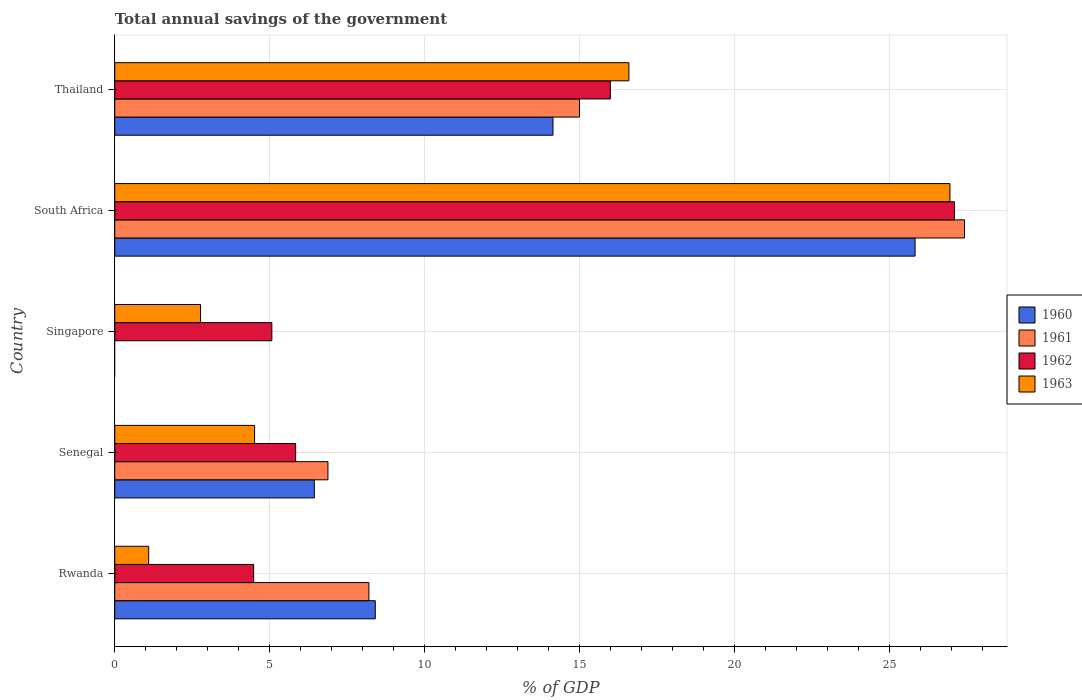How many different coloured bars are there?
Give a very brief answer. 4. Are the number of bars on each tick of the Y-axis equal?
Make the answer very short. No. What is the label of the 2nd group of bars from the top?
Offer a terse response. South Africa. What is the total annual savings of the government in 1960 in Thailand?
Ensure brevity in your answer.  14.13. Across all countries, what is the maximum total annual savings of the government in 1960?
Ensure brevity in your answer.  25.81. In which country was the total annual savings of the government in 1963 maximum?
Make the answer very short. South Africa. What is the total total annual savings of the government in 1962 in the graph?
Make the answer very short. 58.45. What is the difference between the total annual savings of the government in 1961 in Rwanda and that in Thailand?
Provide a short and direct response. -6.79. What is the difference between the total annual savings of the government in 1960 in Rwanda and the total annual savings of the government in 1961 in Senegal?
Provide a succinct answer. 1.53. What is the average total annual savings of the government in 1961 per country?
Keep it short and to the point. 11.49. What is the difference between the total annual savings of the government in 1960 and total annual savings of the government in 1963 in South Africa?
Your answer should be very brief. -1.13. What is the ratio of the total annual savings of the government in 1963 in Senegal to that in Singapore?
Keep it short and to the point. 1.63. Is the total annual savings of the government in 1962 in Rwanda less than that in Thailand?
Provide a succinct answer. Yes. What is the difference between the highest and the second highest total annual savings of the government in 1960?
Ensure brevity in your answer.  11.68. What is the difference between the highest and the lowest total annual savings of the government in 1960?
Provide a succinct answer. 25.81. In how many countries, is the total annual savings of the government in 1961 greater than the average total annual savings of the government in 1961 taken over all countries?
Provide a short and direct response. 2. Is the sum of the total annual savings of the government in 1961 in South Africa and Thailand greater than the maximum total annual savings of the government in 1962 across all countries?
Make the answer very short. Yes. Is it the case that in every country, the sum of the total annual savings of the government in 1961 and total annual savings of the government in 1962 is greater than the total annual savings of the government in 1960?
Your response must be concise. Yes. How many bars are there?
Your response must be concise. 18. Are all the bars in the graph horizontal?
Keep it short and to the point. Yes. What is the difference between two consecutive major ticks on the X-axis?
Your answer should be compact. 5. Are the values on the major ticks of X-axis written in scientific E-notation?
Give a very brief answer. No. How are the legend labels stacked?
Give a very brief answer. Vertical. What is the title of the graph?
Your answer should be very brief. Total annual savings of the government. What is the label or title of the X-axis?
Your answer should be compact. % of GDP. What is the label or title of the Y-axis?
Your answer should be compact. Country. What is the % of GDP in 1960 in Rwanda?
Give a very brief answer. 8.4. What is the % of GDP in 1961 in Rwanda?
Ensure brevity in your answer.  8.2. What is the % of GDP in 1962 in Rwanda?
Provide a succinct answer. 4.48. What is the % of GDP in 1963 in Rwanda?
Make the answer very short. 1.09. What is the % of GDP in 1960 in Senegal?
Provide a short and direct response. 6.44. What is the % of GDP of 1961 in Senegal?
Give a very brief answer. 6.88. What is the % of GDP in 1962 in Senegal?
Provide a succinct answer. 5.83. What is the % of GDP in 1963 in Senegal?
Keep it short and to the point. 4.51. What is the % of GDP of 1962 in Singapore?
Offer a very short reply. 5.07. What is the % of GDP of 1963 in Singapore?
Your answer should be compact. 2.77. What is the % of GDP of 1960 in South Africa?
Your answer should be compact. 25.81. What is the % of GDP of 1961 in South Africa?
Your answer should be compact. 27.41. What is the % of GDP of 1962 in South Africa?
Ensure brevity in your answer.  27.08. What is the % of GDP in 1963 in South Africa?
Ensure brevity in your answer.  26.94. What is the % of GDP of 1960 in Thailand?
Keep it short and to the point. 14.13. What is the % of GDP of 1961 in Thailand?
Your response must be concise. 14.99. What is the % of GDP of 1962 in Thailand?
Ensure brevity in your answer.  15.99. What is the % of GDP of 1963 in Thailand?
Your answer should be compact. 16.58. Across all countries, what is the maximum % of GDP in 1960?
Your response must be concise. 25.81. Across all countries, what is the maximum % of GDP of 1961?
Your answer should be very brief. 27.41. Across all countries, what is the maximum % of GDP in 1962?
Your response must be concise. 27.08. Across all countries, what is the maximum % of GDP in 1963?
Your answer should be very brief. 26.94. Across all countries, what is the minimum % of GDP in 1960?
Your answer should be compact. 0. Across all countries, what is the minimum % of GDP of 1962?
Ensure brevity in your answer.  4.48. Across all countries, what is the minimum % of GDP in 1963?
Make the answer very short. 1.09. What is the total % of GDP in 1960 in the graph?
Your answer should be very brief. 54.79. What is the total % of GDP in 1961 in the graph?
Provide a short and direct response. 57.47. What is the total % of GDP in 1962 in the graph?
Keep it short and to the point. 58.45. What is the total % of GDP in 1963 in the graph?
Keep it short and to the point. 51.9. What is the difference between the % of GDP of 1960 in Rwanda and that in Senegal?
Offer a terse response. 1.97. What is the difference between the % of GDP in 1961 in Rwanda and that in Senegal?
Your answer should be compact. 1.32. What is the difference between the % of GDP of 1962 in Rwanda and that in Senegal?
Your answer should be compact. -1.35. What is the difference between the % of GDP in 1963 in Rwanda and that in Senegal?
Keep it short and to the point. -3.42. What is the difference between the % of GDP of 1962 in Rwanda and that in Singapore?
Offer a terse response. -0.59. What is the difference between the % of GDP in 1963 in Rwanda and that in Singapore?
Ensure brevity in your answer.  -1.67. What is the difference between the % of GDP in 1960 in Rwanda and that in South Africa?
Ensure brevity in your answer.  -17.41. What is the difference between the % of GDP in 1961 in Rwanda and that in South Africa?
Ensure brevity in your answer.  -19.21. What is the difference between the % of GDP of 1962 in Rwanda and that in South Africa?
Your answer should be compact. -22.6. What is the difference between the % of GDP in 1963 in Rwanda and that in South Africa?
Ensure brevity in your answer.  -25.85. What is the difference between the % of GDP in 1960 in Rwanda and that in Thailand?
Make the answer very short. -5.73. What is the difference between the % of GDP of 1961 in Rwanda and that in Thailand?
Ensure brevity in your answer.  -6.79. What is the difference between the % of GDP of 1962 in Rwanda and that in Thailand?
Offer a very short reply. -11.51. What is the difference between the % of GDP in 1963 in Rwanda and that in Thailand?
Offer a very short reply. -15.49. What is the difference between the % of GDP in 1962 in Senegal and that in Singapore?
Provide a short and direct response. 0.77. What is the difference between the % of GDP in 1963 in Senegal and that in Singapore?
Make the answer very short. 1.74. What is the difference between the % of GDP of 1960 in Senegal and that in South Africa?
Offer a very short reply. -19.38. What is the difference between the % of GDP in 1961 in Senegal and that in South Africa?
Offer a very short reply. -20.53. What is the difference between the % of GDP of 1962 in Senegal and that in South Africa?
Offer a very short reply. -21.25. What is the difference between the % of GDP in 1963 in Senegal and that in South Africa?
Offer a terse response. -22.43. What is the difference between the % of GDP of 1960 in Senegal and that in Thailand?
Offer a very short reply. -7.7. What is the difference between the % of GDP of 1961 in Senegal and that in Thailand?
Your answer should be compact. -8.11. What is the difference between the % of GDP in 1962 in Senegal and that in Thailand?
Your answer should be compact. -10.15. What is the difference between the % of GDP of 1963 in Senegal and that in Thailand?
Your answer should be very brief. -12.07. What is the difference between the % of GDP in 1962 in Singapore and that in South Africa?
Give a very brief answer. -22.02. What is the difference between the % of GDP in 1963 in Singapore and that in South Africa?
Ensure brevity in your answer.  -24.17. What is the difference between the % of GDP in 1962 in Singapore and that in Thailand?
Provide a short and direct response. -10.92. What is the difference between the % of GDP in 1963 in Singapore and that in Thailand?
Offer a very short reply. -13.82. What is the difference between the % of GDP in 1960 in South Africa and that in Thailand?
Offer a very short reply. 11.68. What is the difference between the % of GDP in 1961 in South Africa and that in Thailand?
Your answer should be very brief. 12.42. What is the difference between the % of GDP in 1962 in South Africa and that in Thailand?
Your answer should be very brief. 11.1. What is the difference between the % of GDP of 1963 in South Africa and that in Thailand?
Ensure brevity in your answer.  10.36. What is the difference between the % of GDP of 1960 in Rwanda and the % of GDP of 1961 in Senegal?
Offer a terse response. 1.53. What is the difference between the % of GDP in 1960 in Rwanda and the % of GDP in 1962 in Senegal?
Make the answer very short. 2.57. What is the difference between the % of GDP of 1960 in Rwanda and the % of GDP of 1963 in Senegal?
Your answer should be very brief. 3.89. What is the difference between the % of GDP in 1961 in Rwanda and the % of GDP in 1962 in Senegal?
Make the answer very short. 2.36. What is the difference between the % of GDP of 1961 in Rwanda and the % of GDP of 1963 in Senegal?
Make the answer very short. 3.69. What is the difference between the % of GDP of 1962 in Rwanda and the % of GDP of 1963 in Senegal?
Make the answer very short. -0.03. What is the difference between the % of GDP of 1960 in Rwanda and the % of GDP of 1962 in Singapore?
Your response must be concise. 3.34. What is the difference between the % of GDP in 1960 in Rwanda and the % of GDP in 1963 in Singapore?
Your response must be concise. 5.64. What is the difference between the % of GDP in 1961 in Rwanda and the % of GDP in 1962 in Singapore?
Make the answer very short. 3.13. What is the difference between the % of GDP in 1961 in Rwanda and the % of GDP in 1963 in Singapore?
Offer a very short reply. 5.43. What is the difference between the % of GDP in 1962 in Rwanda and the % of GDP in 1963 in Singapore?
Provide a succinct answer. 1.71. What is the difference between the % of GDP in 1960 in Rwanda and the % of GDP in 1961 in South Africa?
Offer a very short reply. -19.01. What is the difference between the % of GDP in 1960 in Rwanda and the % of GDP in 1962 in South Africa?
Your response must be concise. -18.68. What is the difference between the % of GDP of 1960 in Rwanda and the % of GDP of 1963 in South Africa?
Offer a very short reply. -18.54. What is the difference between the % of GDP in 1961 in Rwanda and the % of GDP in 1962 in South Africa?
Your response must be concise. -18.89. What is the difference between the % of GDP in 1961 in Rwanda and the % of GDP in 1963 in South Africa?
Your response must be concise. -18.74. What is the difference between the % of GDP of 1962 in Rwanda and the % of GDP of 1963 in South Africa?
Provide a short and direct response. -22.46. What is the difference between the % of GDP of 1960 in Rwanda and the % of GDP of 1961 in Thailand?
Ensure brevity in your answer.  -6.59. What is the difference between the % of GDP in 1960 in Rwanda and the % of GDP in 1962 in Thailand?
Give a very brief answer. -7.58. What is the difference between the % of GDP of 1960 in Rwanda and the % of GDP of 1963 in Thailand?
Your response must be concise. -8.18. What is the difference between the % of GDP in 1961 in Rwanda and the % of GDP in 1962 in Thailand?
Offer a terse response. -7.79. What is the difference between the % of GDP in 1961 in Rwanda and the % of GDP in 1963 in Thailand?
Your response must be concise. -8.39. What is the difference between the % of GDP in 1962 in Rwanda and the % of GDP in 1963 in Thailand?
Your response must be concise. -12.1. What is the difference between the % of GDP of 1960 in Senegal and the % of GDP of 1962 in Singapore?
Your response must be concise. 1.37. What is the difference between the % of GDP of 1960 in Senegal and the % of GDP of 1963 in Singapore?
Your answer should be very brief. 3.67. What is the difference between the % of GDP of 1961 in Senegal and the % of GDP of 1962 in Singapore?
Your response must be concise. 1.81. What is the difference between the % of GDP in 1961 in Senegal and the % of GDP in 1963 in Singapore?
Your response must be concise. 4.11. What is the difference between the % of GDP in 1962 in Senegal and the % of GDP in 1963 in Singapore?
Make the answer very short. 3.07. What is the difference between the % of GDP of 1960 in Senegal and the % of GDP of 1961 in South Africa?
Give a very brief answer. -20.97. What is the difference between the % of GDP of 1960 in Senegal and the % of GDP of 1962 in South Africa?
Offer a terse response. -20.65. What is the difference between the % of GDP in 1960 in Senegal and the % of GDP in 1963 in South Africa?
Your answer should be compact. -20.5. What is the difference between the % of GDP in 1961 in Senegal and the % of GDP in 1962 in South Africa?
Your answer should be very brief. -20.21. What is the difference between the % of GDP in 1961 in Senegal and the % of GDP in 1963 in South Africa?
Ensure brevity in your answer.  -20.06. What is the difference between the % of GDP in 1962 in Senegal and the % of GDP in 1963 in South Africa?
Your answer should be compact. -21.11. What is the difference between the % of GDP of 1960 in Senegal and the % of GDP of 1961 in Thailand?
Offer a very short reply. -8.55. What is the difference between the % of GDP in 1960 in Senegal and the % of GDP in 1962 in Thailand?
Ensure brevity in your answer.  -9.55. What is the difference between the % of GDP in 1960 in Senegal and the % of GDP in 1963 in Thailand?
Ensure brevity in your answer.  -10.15. What is the difference between the % of GDP in 1961 in Senegal and the % of GDP in 1962 in Thailand?
Keep it short and to the point. -9.11. What is the difference between the % of GDP of 1961 in Senegal and the % of GDP of 1963 in Thailand?
Provide a short and direct response. -9.71. What is the difference between the % of GDP in 1962 in Senegal and the % of GDP in 1963 in Thailand?
Offer a terse response. -10.75. What is the difference between the % of GDP in 1962 in Singapore and the % of GDP in 1963 in South Africa?
Provide a short and direct response. -21.87. What is the difference between the % of GDP of 1962 in Singapore and the % of GDP of 1963 in Thailand?
Give a very brief answer. -11.52. What is the difference between the % of GDP of 1960 in South Africa and the % of GDP of 1961 in Thailand?
Your response must be concise. 10.83. What is the difference between the % of GDP in 1960 in South Africa and the % of GDP in 1962 in Thailand?
Give a very brief answer. 9.83. What is the difference between the % of GDP of 1960 in South Africa and the % of GDP of 1963 in Thailand?
Your answer should be very brief. 9.23. What is the difference between the % of GDP of 1961 in South Africa and the % of GDP of 1962 in Thailand?
Offer a terse response. 11.42. What is the difference between the % of GDP of 1961 in South Africa and the % of GDP of 1963 in Thailand?
Keep it short and to the point. 10.82. What is the difference between the % of GDP of 1962 in South Africa and the % of GDP of 1963 in Thailand?
Offer a terse response. 10.5. What is the average % of GDP of 1960 per country?
Offer a terse response. 10.96. What is the average % of GDP in 1961 per country?
Provide a succinct answer. 11.49. What is the average % of GDP in 1962 per country?
Offer a terse response. 11.69. What is the average % of GDP in 1963 per country?
Provide a short and direct response. 10.38. What is the difference between the % of GDP of 1960 and % of GDP of 1961 in Rwanda?
Make the answer very short. 0.21. What is the difference between the % of GDP of 1960 and % of GDP of 1962 in Rwanda?
Provide a succinct answer. 3.92. What is the difference between the % of GDP in 1960 and % of GDP in 1963 in Rwanda?
Your answer should be very brief. 7.31. What is the difference between the % of GDP of 1961 and % of GDP of 1962 in Rwanda?
Make the answer very short. 3.72. What is the difference between the % of GDP in 1961 and % of GDP in 1963 in Rwanda?
Offer a terse response. 7.1. What is the difference between the % of GDP of 1962 and % of GDP of 1963 in Rwanda?
Make the answer very short. 3.39. What is the difference between the % of GDP of 1960 and % of GDP of 1961 in Senegal?
Provide a succinct answer. -0.44. What is the difference between the % of GDP of 1960 and % of GDP of 1962 in Senegal?
Provide a short and direct response. 0.6. What is the difference between the % of GDP of 1960 and % of GDP of 1963 in Senegal?
Offer a very short reply. 1.93. What is the difference between the % of GDP in 1961 and % of GDP in 1962 in Senegal?
Make the answer very short. 1.04. What is the difference between the % of GDP in 1961 and % of GDP in 1963 in Senegal?
Make the answer very short. 2.37. What is the difference between the % of GDP of 1962 and % of GDP of 1963 in Senegal?
Offer a very short reply. 1.32. What is the difference between the % of GDP in 1962 and % of GDP in 1963 in Singapore?
Your answer should be compact. 2.3. What is the difference between the % of GDP of 1960 and % of GDP of 1961 in South Africa?
Make the answer very short. -1.59. What is the difference between the % of GDP of 1960 and % of GDP of 1962 in South Africa?
Ensure brevity in your answer.  -1.27. What is the difference between the % of GDP in 1960 and % of GDP in 1963 in South Africa?
Your response must be concise. -1.13. What is the difference between the % of GDP in 1961 and % of GDP in 1962 in South Africa?
Your answer should be compact. 0.33. What is the difference between the % of GDP of 1961 and % of GDP of 1963 in South Africa?
Give a very brief answer. 0.47. What is the difference between the % of GDP of 1962 and % of GDP of 1963 in South Africa?
Provide a succinct answer. 0.14. What is the difference between the % of GDP of 1960 and % of GDP of 1961 in Thailand?
Ensure brevity in your answer.  -0.85. What is the difference between the % of GDP in 1960 and % of GDP in 1962 in Thailand?
Your answer should be compact. -1.85. What is the difference between the % of GDP in 1960 and % of GDP in 1963 in Thailand?
Your answer should be very brief. -2.45. What is the difference between the % of GDP of 1961 and % of GDP of 1962 in Thailand?
Your answer should be compact. -1. What is the difference between the % of GDP in 1961 and % of GDP in 1963 in Thailand?
Provide a succinct answer. -1.59. What is the difference between the % of GDP of 1962 and % of GDP of 1963 in Thailand?
Ensure brevity in your answer.  -0.6. What is the ratio of the % of GDP of 1960 in Rwanda to that in Senegal?
Make the answer very short. 1.31. What is the ratio of the % of GDP in 1961 in Rwanda to that in Senegal?
Your answer should be very brief. 1.19. What is the ratio of the % of GDP of 1962 in Rwanda to that in Senegal?
Offer a very short reply. 0.77. What is the ratio of the % of GDP in 1963 in Rwanda to that in Senegal?
Ensure brevity in your answer.  0.24. What is the ratio of the % of GDP of 1962 in Rwanda to that in Singapore?
Your answer should be very brief. 0.88. What is the ratio of the % of GDP of 1963 in Rwanda to that in Singapore?
Keep it short and to the point. 0.4. What is the ratio of the % of GDP of 1960 in Rwanda to that in South Africa?
Ensure brevity in your answer.  0.33. What is the ratio of the % of GDP of 1961 in Rwanda to that in South Africa?
Your response must be concise. 0.3. What is the ratio of the % of GDP in 1962 in Rwanda to that in South Africa?
Your answer should be very brief. 0.17. What is the ratio of the % of GDP of 1963 in Rwanda to that in South Africa?
Your response must be concise. 0.04. What is the ratio of the % of GDP in 1960 in Rwanda to that in Thailand?
Provide a succinct answer. 0.59. What is the ratio of the % of GDP of 1961 in Rwanda to that in Thailand?
Offer a terse response. 0.55. What is the ratio of the % of GDP in 1962 in Rwanda to that in Thailand?
Give a very brief answer. 0.28. What is the ratio of the % of GDP in 1963 in Rwanda to that in Thailand?
Make the answer very short. 0.07. What is the ratio of the % of GDP of 1962 in Senegal to that in Singapore?
Your answer should be very brief. 1.15. What is the ratio of the % of GDP in 1963 in Senegal to that in Singapore?
Keep it short and to the point. 1.63. What is the ratio of the % of GDP in 1960 in Senegal to that in South Africa?
Make the answer very short. 0.25. What is the ratio of the % of GDP in 1961 in Senegal to that in South Africa?
Provide a succinct answer. 0.25. What is the ratio of the % of GDP of 1962 in Senegal to that in South Africa?
Keep it short and to the point. 0.22. What is the ratio of the % of GDP of 1963 in Senegal to that in South Africa?
Your answer should be very brief. 0.17. What is the ratio of the % of GDP in 1960 in Senegal to that in Thailand?
Your response must be concise. 0.46. What is the ratio of the % of GDP of 1961 in Senegal to that in Thailand?
Your answer should be very brief. 0.46. What is the ratio of the % of GDP in 1962 in Senegal to that in Thailand?
Offer a terse response. 0.36. What is the ratio of the % of GDP in 1963 in Senegal to that in Thailand?
Provide a succinct answer. 0.27. What is the ratio of the % of GDP of 1962 in Singapore to that in South Africa?
Offer a very short reply. 0.19. What is the ratio of the % of GDP of 1963 in Singapore to that in South Africa?
Ensure brevity in your answer.  0.1. What is the ratio of the % of GDP in 1962 in Singapore to that in Thailand?
Your answer should be compact. 0.32. What is the ratio of the % of GDP in 1963 in Singapore to that in Thailand?
Offer a very short reply. 0.17. What is the ratio of the % of GDP of 1960 in South Africa to that in Thailand?
Offer a very short reply. 1.83. What is the ratio of the % of GDP of 1961 in South Africa to that in Thailand?
Make the answer very short. 1.83. What is the ratio of the % of GDP in 1962 in South Africa to that in Thailand?
Make the answer very short. 1.69. What is the ratio of the % of GDP in 1963 in South Africa to that in Thailand?
Make the answer very short. 1.62. What is the difference between the highest and the second highest % of GDP of 1960?
Keep it short and to the point. 11.68. What is the difference between the highest and the second highest % of GDP in 1961?
Offer a terse response. 12.42. What is the difference between the highest and the second highest % of GDP of 1962?
Provide a succinct answer. 11.1. What is the difference between the highest and the second highest % of GDP of 1963?
Provide a succinct answer. 10.36. What is the difference between the highest and the lowest % of GDP of 1960?
Your answer should be very brief. 25.81. What is the difference between the highest and the lowest % of GDP of 1961?
Give a very brief answer. 27.41. What is the difference between the highest and the lowest % of GDP of 1962?
Your answer should be compact. 22.6. What is the difference between the highest and the lowest % of GDP of 1963?
Offer a terse response. 25.85. 